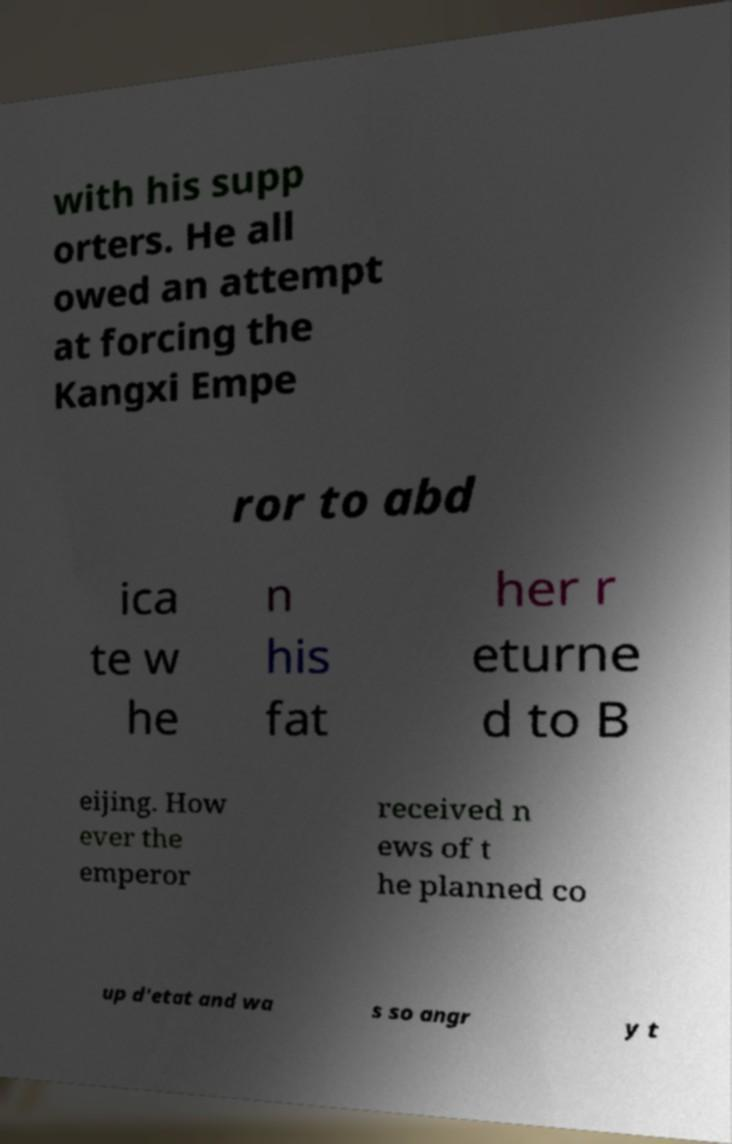I need the written content from this picture converted into text. Can you do that? with his supp orters. He all owed an attempt at forcing the Kangxi Empe ror to abd ica te w he n his fat her r eturne d to B eijing. How ever the emperor received n ews of t he planned co up d'etat and wa s so angr y t 